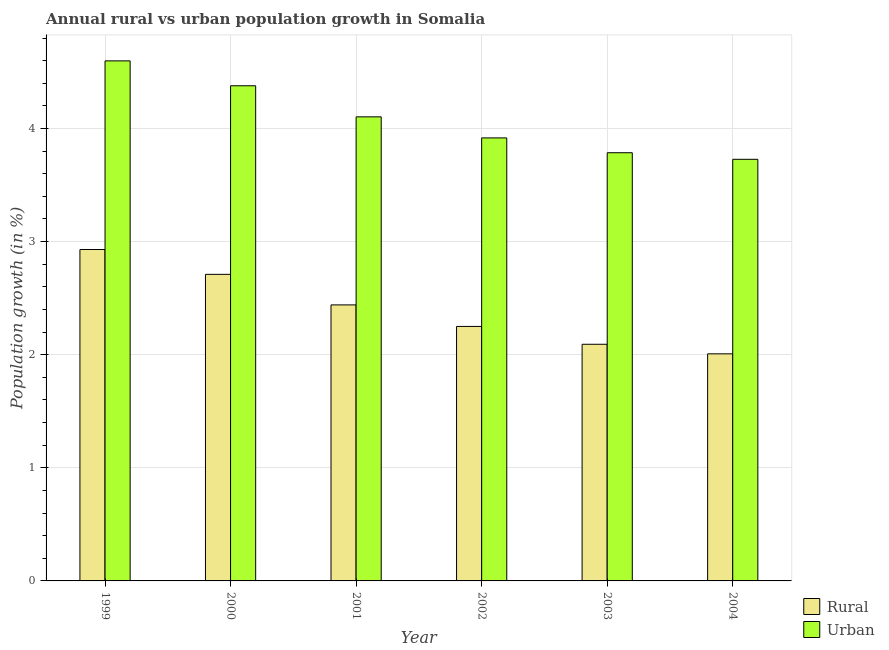Are the number of bars per tick equal to the number of legend labels?
Make the answer very short. Yes. How many bars are there on the 4th tick from the right?
Provide a short and direct response. 2. What is the label of the 6th group of bars from the left?
Give a very brief answer. 2004. In how many cases, is the number of bars for a given year not equal to the number of legend labels?
Ensure brevity in your answer.  0. What is the rural population growth in 2001?
Make the answer very short. 2.44. Across all years, what is the maximum rural population growth?
Offer a terse response. 2.93. Across all years, what is the minimum rural population growth?
Provide a short and direct response. 2.01. In which year was the rural population growth maximum?
Your answer should be very brief. 1999. What is the total urban population growth in the graph?
Make the answer very short. 24.51. What is the difference between the rural population growth in 2001 and that in 2003?
Your answer should be very brief. 0.35. What is the difference between the urban population growth in 2003 and the rural population growth in 2002?
Give a very brief answer. -0.13. What is the average rural population growth per year?
Offer a very short reply. 2.41. In the year 2003, what is the difference between the rural population growth and urban population growth?
Your answer should be compact. 0. In how many years, is the rural population growth greater than 3.8 %?
Your response must be concise. 0. What is the ratio of the rural population growth in 1999 to that in 2002?
Offer a terse response. 1.3. Is the rural population growth in 1999 less than that in 2000?
Provide a short and direct response. No. What is the difference between the highest and the second highest urban population growth?
Give a very brief answer. 0.22. What is the difference between the highest and the lowest rural population growth?
Your answer should be very brief. 0.92. In how many years, is the rural population growth greater than the average rural population growth taken over all years?
Provide a short and direct response. 3. What does the 2nd bar from the left in 2003 represents?
Provide a short and direct response. Urban . What does the 2nd bar from the right in 2000 represents?
Give a very brief answer. Rural. How many years are there in the graph?
Your answer should be compact. 6. What is the difference between two consecutive major ticks on the Y-axis?
Provide a succinct answer. 1. Are the values on the major ticks of Y-axis written in scientific E-notation?
Give a very brief answer. No. Does the graph contain any zero values?
Provide a succinct answer. No. What is the title of the graph?
Keep it short and to the point. Annual rural vs urban population growth in Somalia. What is the label or title of the X-axis?
Your answer should be compact. Year. What is the label or title of the Y-axis?
Provide a short and direct response. Population growth (in %). What is the Population growth (in %) in Rural in 1999?
Give a very brief answer. 2.93. What is the Population growth (in %) in Urban  in 1999?
Make the answer very short. 4.6. What is the Population growth (in %) in Rural in 2000?
Your answer should be very brief. 2.71. What is the Population growth (in %) in Urban  in 2000?
Provide a succinct answer. 4.38. What is the Population growth (in %) of Rural in 2001?
Your answer should be compact. 2.44. What is the Population growth (in %) in Urban  in 2001?
Provide a succinct answer. 4.1. What is the Population growth (in %) of Rural in 2002?
Your response must be concise. 2.25. What is the Population growth (in %) in Urban  in 2002?
Keep it short and to the point. 3.92. What is the Population growth (in %) of Rural in 2003?
Offer a very short reply. 2.09. What is the Population growth (in %) of Urban  in 2003?
Provide a succinct answer. 3.79. What is the Population growth (in %) in Rural in 2004?
Give a very brief answer. 2.01. What is the Population growth (in %) in Urban  in 2004?
Your answer should be very brief. 3.73. Across all years, what is the maximum Population growth (in %) of Rural?
Give a very brief answer. 2.93. Across all years, what is the maximum Population growth (in %) of Urban ?
Provide a succinct answer. 4.6. Across all years, what is the minimum Population growth (in %) in Rural?
Provide a short and direct response. 2.01. Across all years, what is the minimum Population growth (in %) of Urban ?
Offer a very short reply. 3.73. What is the total Population growth (in %) of Rural in the graph?
Offer a terse response. 14.43. What is the total Population growth (in %) of Urban  in the graph?
Offer a very short reply. 24.51. What is the difference between the Population growth (in %) of Rural in 1999 and that in 2000?
Your response must be concise. 0.22. What is the difference between the Population growth (in %) in Urban  in 1999 and that in 2000?
Provide a short and direct response. 0.22. What is the difference between the Population growth (in %) of Rural in 1999 and that in 2001?
Offer a very short reply. 0.49. What is the difference between the Population growth (in %) of Urban  in 1999 and that in 2001?
Give a very brief answer. 0.49. What is the difference between the Population growth (in %) in Rural in 1999 and that in 2002?
Keep it short and to the point. 0.68. What is the difference between the Population growth (in %) of Urban  in 1999 and that in 2002?
Offer a very short reply. 0.68. What is the difference between the Population growth (in %) in Rural in 1999 and that in 2003?
Offer a terse response. 0.84. What is the difference between the Population growth (in %) of Urban  in 1999 and that in 2003?
Provide a short and direct response. 0.81. What is the difference between the Population growth (in %) of Rural in 1999 and that in 2004?
Keep it short and to the point. 0.92. What is the difference between the Population growth (in %) in Urban  in 1999 and that in 2004?
Offer a terse response. 0.87. What is the difference between the Population growth (in %) in Rural in 2000 and that in 2001?
Offer a terse response. 0.27. What is the difference between the Population growth (in %) of Urban  in 2000 and that in 2001?
Provide a succinct answer. 0.27. What is the difference between the Population growth (in %) of Rural in 2000 and that in 2002?
Offer a terse response. 0.46. What is the difference between the Population growth (in %) in Urban  in 2000 and that in 2002?
Your answer should be very brief. 0.46. What is the difference between the Population growth (in %) of Rural in 2000 and that in 2003?
Provide a short and direct response. 0.62. What is the difference between the Population growth (in %) in Urban  in 2000 and that in 2003?
Provide a succinct answer. 0.59. What is the difference between the Population growth (in %) in Rural in 2000 and that in 2004?
Offer a very short reply. 0.7. What is the difference between the Population growth (in %) in Urban  in 2000 and that in 2004?
Provide a succinct answer. 0.65. What is the difference between the Population growth (in %) of Rural in 2001 and that in 2002?
Make the answer very short. 0.19. What is the difference between the Population growth (in %) of Urban  in 2001 and that in 2002?
Your answer should be very brief. 0.19. What is the difference between the Population growth (in %) of Rural in 2001 and that in 2003?
Make the answer very short. 0.35. What is the difference between the Population growth (in %) in Urban  in 2001 and that in 2003?
Your response must be concise. 0.32. What is the difference between the Population growth (in %) in Rural in 2001 and that in 2004?
Your response must be concise. 0.43. What is the difference between the Population growth (in %) of Urban  in 2001 and that in 2004?
Offer a very short reply. 0.38. What is the difference between the Population growth (in %) in Rural in 2002 and that in 2003?
Your answer should be compact. 0.16. What is the difference between the Population growth (in %) in Urban  in 2002 and that in 2003?
Provide a short and direct response. 0.13. What is the difference between the Population growth (in %) in Rural in 2002 and that in 2004?
Your answer should be very brief. 0.24. What is the difference between the Population growth (in %) in Urban  in 2002 and that in 2004?
Keep it short and to the point. 0.19. What is the difference between the Population growth (in %) in Rural in 2003 and that in 2004?
Keep it short and to the point. 0.08. What is the difference between the Population growth (in %) of Urban  in 2003 and that in 2004?
Offer a very short reply. 0.06. What is the difference between the Population growth (in %) of Rural in 1999 and the Population growth (in %) of Urban  in 2000?
Ensure brevity in your answer.  -1.45. What is the difference between the Population growth (in %) in Rural in 1999 and the Population growth (in %) in Urban  in 2001?
Offer a very short reply. -1.17. What is the difference between the Population growth (in %) in Rural in 1999 and the Population growth (in %) in Urban  in 2002?
Your answer should be very brief. -0.99. What is the difference between the Population growth (in %) in Rural in 1999 and the Population growth (in %) in Urban  in 2003?
Keep it short and to the point. -0.86. What is the difference between the Population growth (in %) of Rural in 1999 and the Population growth (in %) of Urban  in 2004?
Your response must be concise. -0.8. What is the difference between the Population growth (in %) of Rural in 2000 and the Population growth (in %) of Urban  in 2001?
Ensure brevity in your answer.  -1.39. What is the difference between the Population growth (in %) of Rural in 2000 and the Population growth (in %) of Urban  in 2002?
Offer a terse response. -1.21. What is the difference between the Population growth (in %) in Rural in 2000 and the Population growth (in %) in Urban  in 2003?
Provide a succinct answer. -1.08. What is the difference between the Population growth (in %) in Rural in 2000 and the Population growth (in %) in Urban  in 2004?
Provide a short and direct response. -1.02. What is the difference between the Population growth (in %) of Rural in 2001 and the Population growth (in %) of Urban  in 2002?
Your response must be concise. -1.48. What is the difference between the Population growth (in %) in Rural in 2001 and the Population growth (in %) in Urban  in 2003?
Your response must be concise. -1.35. What is the difference between the Population growth (in %) in Rural in 2001 and the Population growth (in %) in Urban  in 2004?
Provide a short and direct response. -1.29. What is the difference between the Population growth (in %) of Rural in 2002 and the Population growth (in %) of Urban  in 2003?
Make the answer very short. -1.54. What is the difference between the Population growth (in %) of Rural in 2002 and the Population growth (in %) of Urban  in 2004?
Provide a succinct answer. -1.48. What is the difference between the Population growth (in %) in Rural in 2003 and the Population growth (in %) in Urban  in 2004?
Your answer should be very brief. -1.64. What is the average Population growth (in %) in Rural per year?
Your answer should be compact. 2.41. What is the average Population growth (in %) in Urban  per year?
Offer a terse response. 4.08. In the year 1999, what is the difference between the Population growth (in %) of Rural and Population growth (in %) of Urban ?
Your answer should be compact. -1.67. In the year 2000, what is the difference between the Population growth (in %) of Rural and Population growth (in %) of Urban ?
Your answer should be compact. -1.67. In the year 2001, what is the difference between the Population growth (in %) of Rural and Population growth (in %) of Urban ?
Your response must be concise. -1.66. In the year 2002, what is the difference between the Population growth (in %) of Rural and Population growth (in %) of Urban ?
Provide a short and direct response. -1.67. In the year 2003, what is the difference between the Population growth (in %) of Rural and Population growth (in %) of Urban ?
Give a very brief answer. -1.69. In the year 2004, what is the difference between the Population growth (in %) in Rural and Population growth (in %) in Urban ?
Provide a short and direct response. -1.72. What is the ratio of the Population growth (in %) of Rural in 1999 to that in 2000?
Ensure brevity in your answer.  1.08. What is the ratio of the Population growth (in %) of Urban  in 1999 to that in 2000?
Make the answer very short. 1.05. What is the ratio of the Population growth (in %) in Rural in 1999 to that in 2001?
Your answer should be compact. 1.2. What is the ratio of the Population growth (in %) of Urban  in 1999 to that in 2001?
Provide a succinct answer. 1.12. What is the ratio of the Population growth (in %) in Rural in 1999 to that in 2002?
Provide a succinct answer. 1.3. What is the ratio of the Population growth (in %) in Urban  in 1999 to that in 2002?
Keep it short and to the point. 1.17. What is the ratio of the Population growth (in %) in Rural in 1999 to that in 2003?
Offer a terse response. 1.4. What is the ratio of the Population growth (in %) of Urban  in 1999 to that in 2003?
Give a very brief answer. 1.21. What is the ratio of the Population growth (in %) of Rural in 1999 to that in 2004?
Your answer should be very brief. 1.46. What is the ratio of the Population growth (in %) of Urban  in 1999 to that in 2004?
Your answer should be very brief. 1.23. What is the ratio of the Population growth (in %) of Rural in 2000 to that in 2001?
Keep it short and to the point. 1.11. What is the ratio of the Population growth (in %) in Urban  in 2000 to that in 2001?
Offer a terse response. 1.07. What is the ratio of the Population growth (in %) of Rural in 2000 to that in 2002?
Offer a terse response. 1.2. What is the ratio of the Population growth (in %) in Urban  in 2000 to that in 2002?
Your response must be concise. 1.12. What is the ratio of the Population growth (in %) in Rural in 2000 to that in 2003?
Offer a terse response. 1.3. What is the ratio of the Population growth (in %) of Urban  in 2000 to that in 2003?
Your answer should be compact. 1.16. What is the ratio of the Population growth (in %) of Rural in 2000 to that in 2004?
Your answer should be compact. 1.35. What is the ratio of the Population growth (in %) of Urban  in 2000 to that in 2004?
Keep it short and to the point. 1.17. What is the ratio of the Population growth (in %) in Rural in 2001 to that in 2002?
Your answer should be compact. 1.08. What is the ratio of the Population growth (in %) in Urban  in 2001 to that in 2002?
Your answer should be very brief. 1.05. What is the ratio of the Population growth (in %) of Rural in 2001 to that in 2003?
Your answer should be very brief. 1.17. What is the ratio of the Population growth (in %) of Urban  in 2001 to that in 2003?
Offer a terse response. 1.08. What is the ratio of the Population growth (in %) in Rural in 2001 to that in 2004?
Your answer should be compact. 1.22. What is the ratio of the Population growth (in %) of Urban  in 2001 to that in 2004?
Keep it short and to the point. 1.1. What is the ratio of the Population growth (in %) of Rural in 2002 to that in 2003?
Provide a short and direct response. 1.08. What is the ratio of the Population growth (in %) of Urban  in 2002 to that in 2003?
Give a very brief answer. 1.03. What is the ratio of the Population growth (in %) in Rural in 2002 to that in 2004?
Make the answer very short. 1.12. What is the ratio of the Population growth (in %) in Urban  in 2002 to that in 2004?
Your answer should be compact. 1.05. What is the ratio of the Population growth (in %) of Rural in 2003 to that in 2004?
Your response must be concise. 1.04. What is the ratio of the Population growth (in %) of Urban  in 2003 to that in 2004?
Your answer should be very brief. 1.02. What is the difference between the highest and the second highest Population growth (in %) of Rural?
Provide a succinct answer. 0.22. What is the difference between the highest and the second highest Population growth (in %) of Urban ?
Your answer should be compact. 0.22. What is the difference between the highest and the lowest Population growth (in %) of Rural?
Keep it short and to the point. 0.92. What is the difference between the highest and the lowest Population growth (in %) in Urban ?
Make the answer very short. 0.87. 